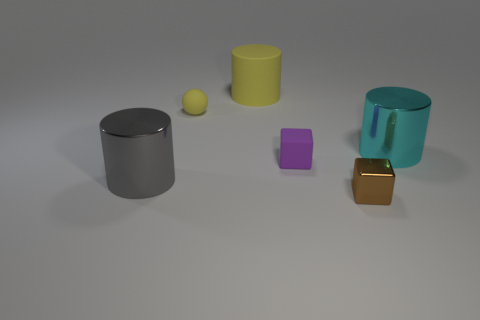Add 3 tiny metallic objects. How many objects exist? 9 Subtract all cubes. How many objects are left? 4 Add 5 large gray cylinders. How many large gray cylinders are left? 6 Add 2 tiny brown metallic cubes. How many tiny brown metallic cubes exist? 3 Subtract 1 brown cubes. How many objects are left? 5 Subtract all big cyan things. Subtract all large yellow objects. How many objects are left? 4 